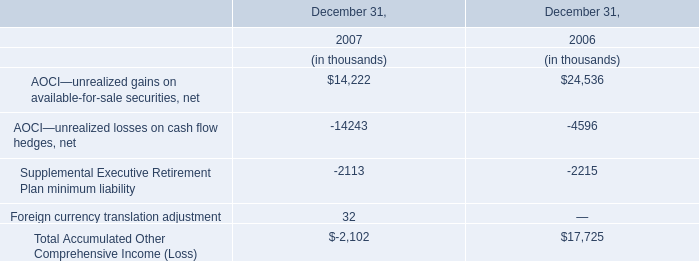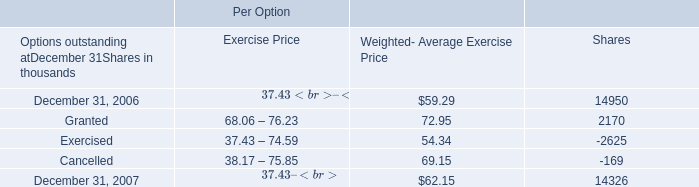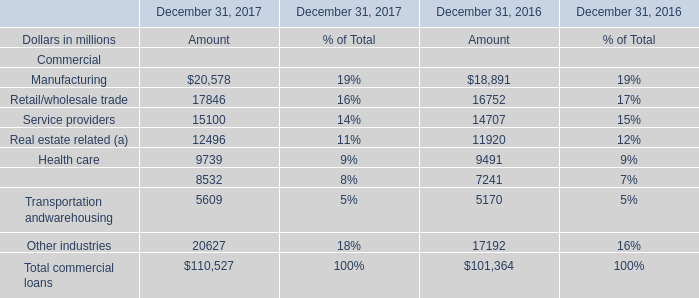What is the sum of Manufacturing for Amount in 2017 and AOCI—unrealized gains on available-for-sale securities, net in 2007 ? 
Computations: (20578 + 14222)
Answer: 34800.0. 